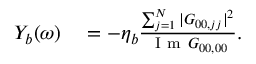<formula> <loc_0><loc_0><loc_500><loc_500>\begin{array} { r l } { Y _ { b } ( \omega ) } & = - \eta _ { b } \frac { \sum _ { j = 1 } ^ { N } | G _ { 0 0 , j j } | ^ { 2 } } { I m G _ { 0 0 , 0 0 } } . } \end{array}</formula> 